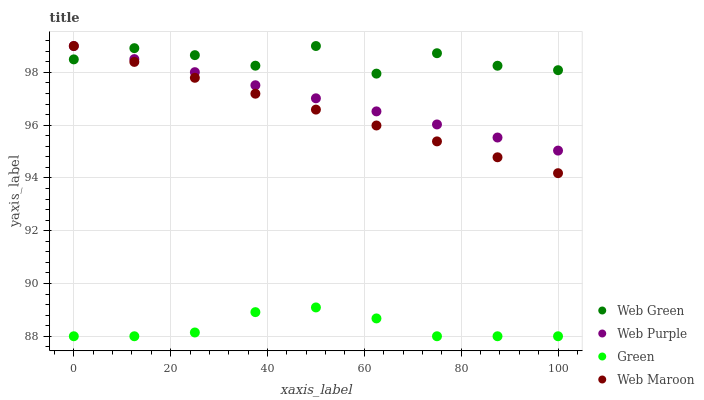Does Green have the minimum area under the curve?
Answer yes or no. Yes. Does Web Green have the maximum area under the curve?
Answer yes or no. Yes. Does Web Purple have the minimum area under the curve?
Answer yes or no. No. Does Web Purple have the maximum area under the curve?
Answer yes or no. No. Is Web Purple the smoothest?
Answer yes or no. Yes. Is Web Green the roughest?
Answer yes or no. Yes. Is Green the smoothest?
Answer yes or no. No. Is Green the roughest?
Answer yes or no. No. Does Green have the lowest value?
Answer yes or no. Yes. Does Web Purple have the lowest value?
Answer yes or no. No. Does Web Green have the highest value?
Answer yes or no. Yes. Does Green have the highest value?
Answer yes or no. No. Is Green less than Web Purple?
Answer yes or no. Yes. Is Web Purple greater than Green?
Answer yes or no. Yes. Does Web Purple intersect Web Green?
Answer yes or no. Yes. Is Web Purple less than Web Green?
Answer yes or no. No. Is Web Purple greater than Web Green?
Answer yes or no. No. Does Green intersect Web Purple?
Answer yes or no. No. 